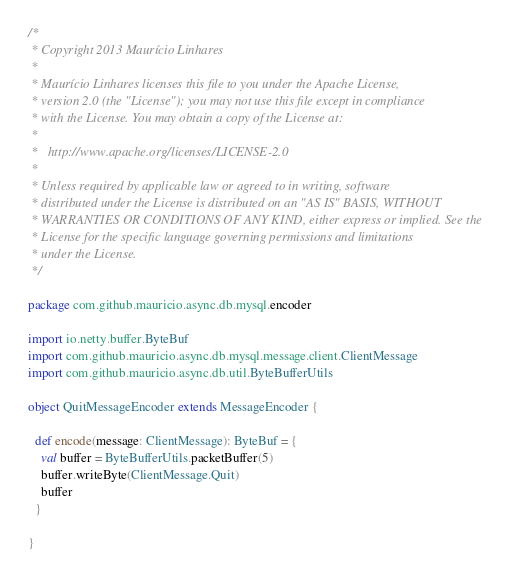<code> <loc_0><loc_0><loc_500><loc_500><_Scala_>/*
 * Copyright 2013 Maurício Linhares
 *
 * Maurício Linhares licenses this file to you under the Apache License,
 * version 2.0 (the "License"); you may not use this file except in compliance
 * with the License. You may obtain a copy of the License at:
 *
 *   http://www.apache.org/licenses/LICENSE-2.0
 *
 * Unless required by applicable law or agreed to in writing, software
 * distributed under the License is distributed on an "AS IS" BASIS, WITHOUT
 * WARRANTIES OR CONDITIONS OF ANY KIND, either express or implied. See the
 * License for the specific language governing permissions and limitations
 * under the License.
 */

package com.github.mauricio.async.db.mysql.encoder

import io.netty.buffer.ByteBuf
import com.github.mauricio.async.db.mysql.message.client.ClientMessage
import com.github.mauricio.async.db.util.ByteBufferUtils

object QuitMessageEncoder extends MessageEncoder {

  def encode(message: ClientMessage): ByteBuf = {
    val buffer = ByteBufferUtils.packetBuffer(5)
    buffer.writeByte(ClientMessage.Quit)
    buffer
  }

}
</code> 